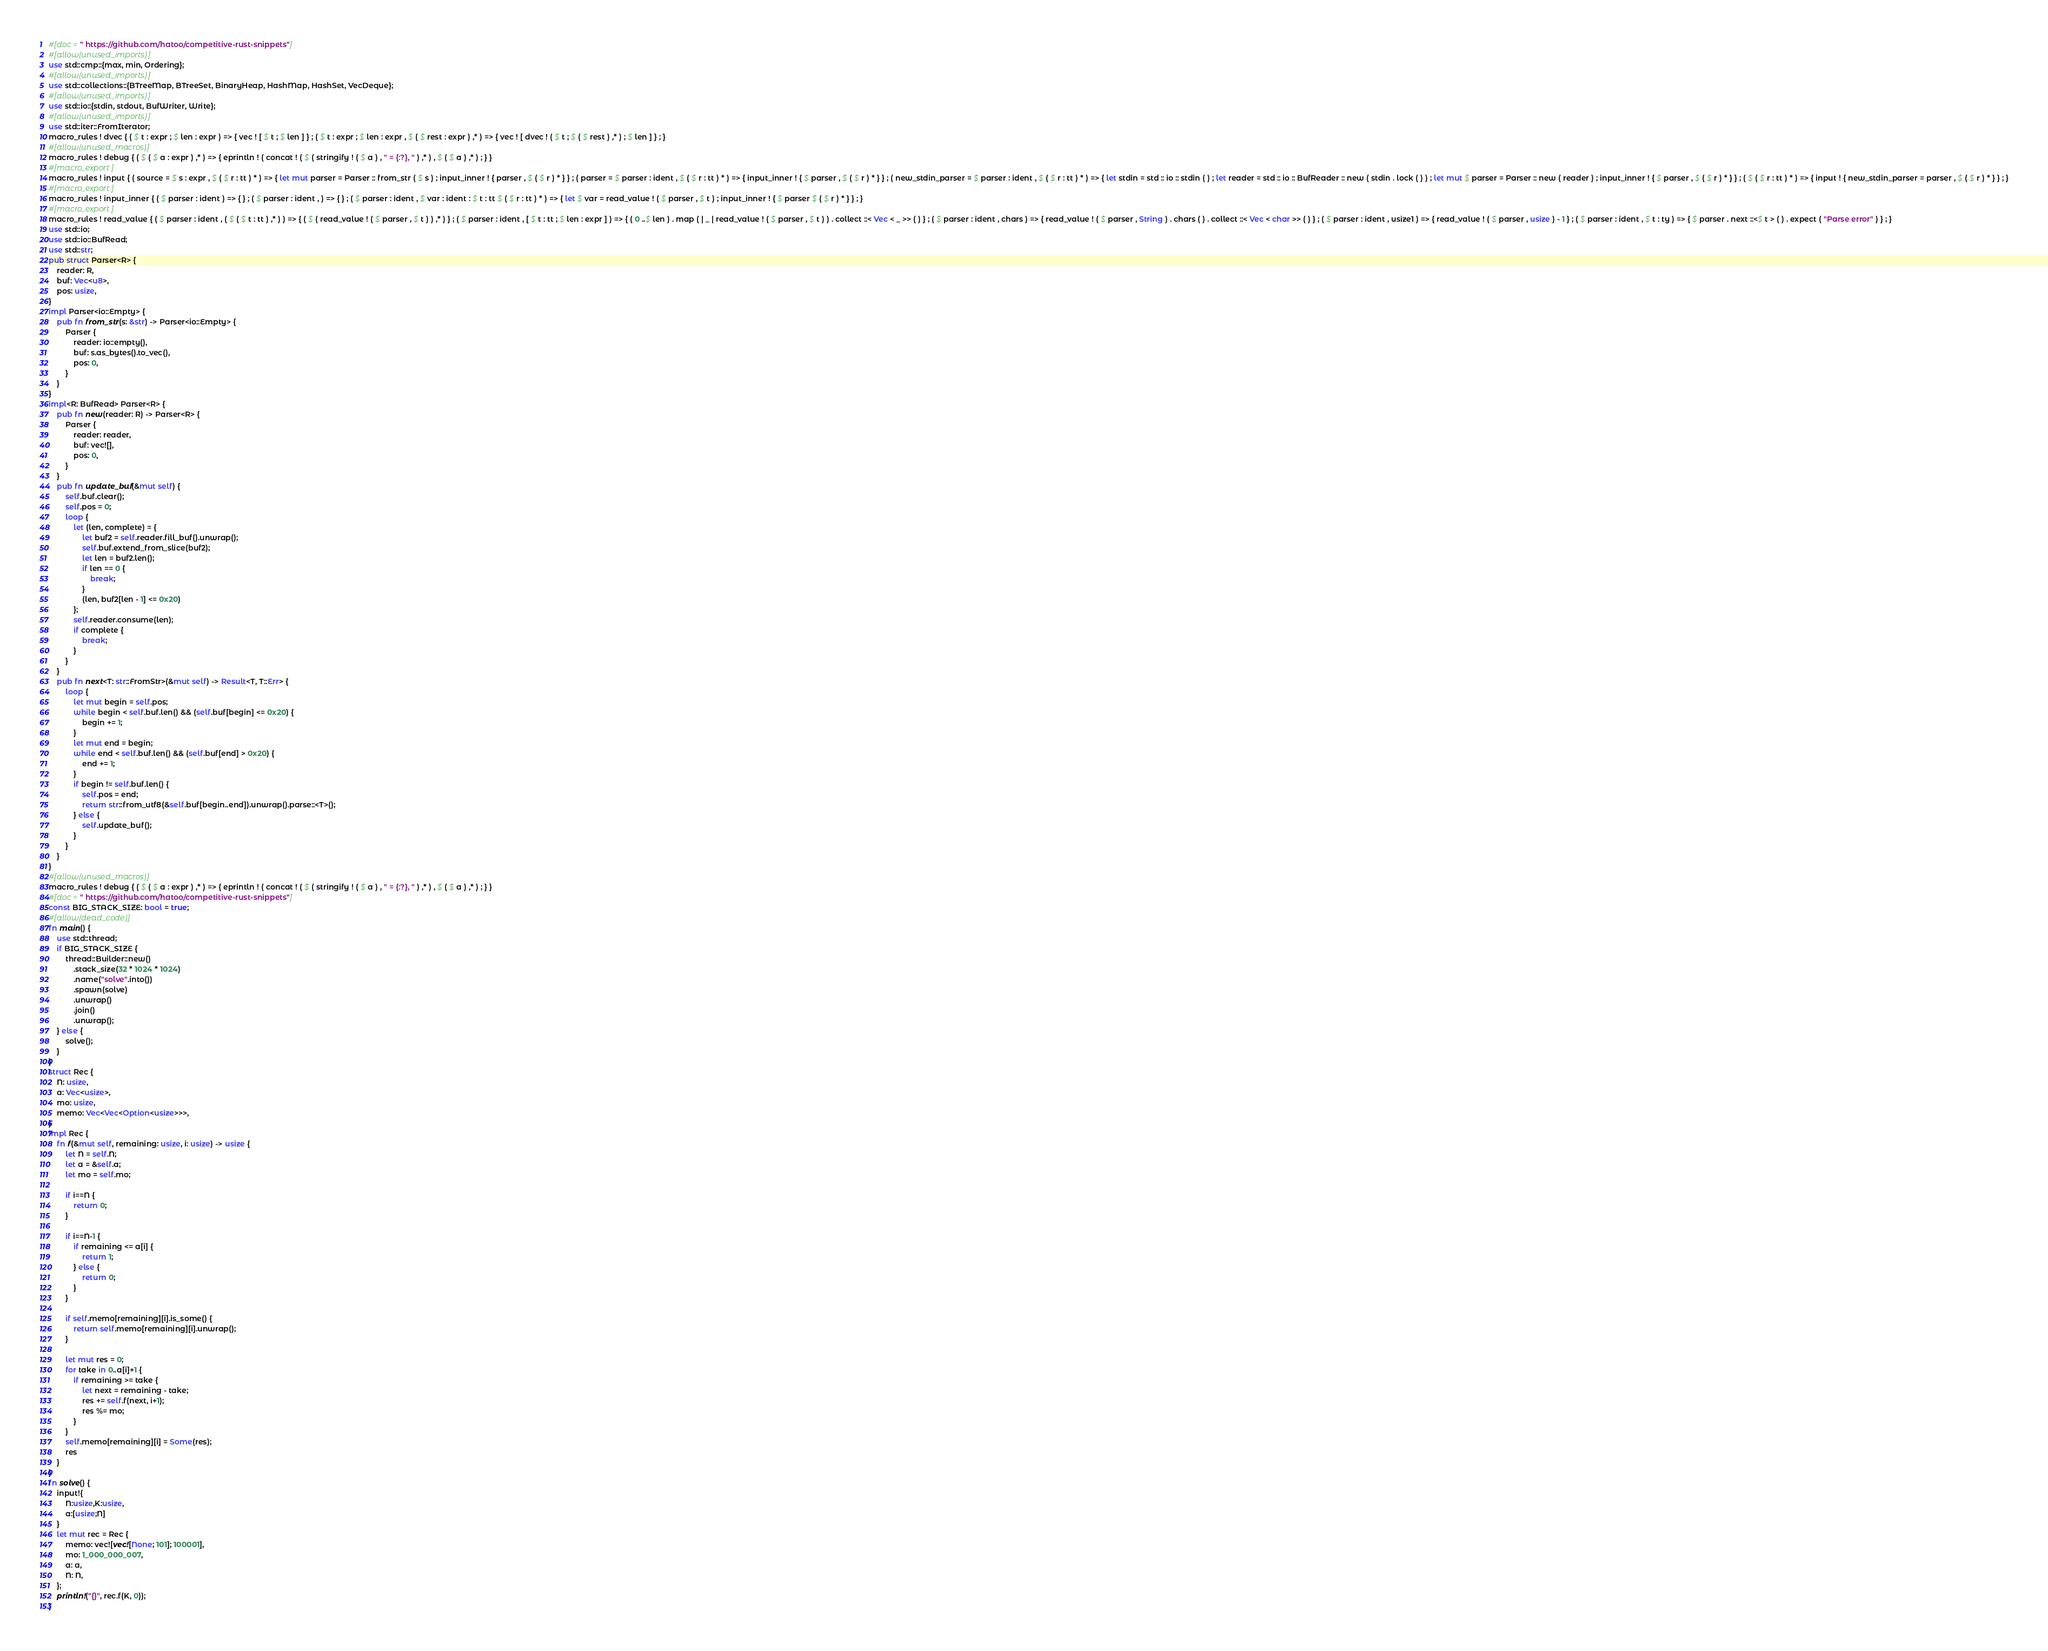<code> <loc_0><loc_0><loc_500><loc_500><_Rust_>#[doc = " https://github.com/hatoo/competitive-rust-snippets"]
#[allow(unused_imports)]
use std::cmp::{max, min, Ordering};
#[allow(unused_imports)]
use std::collections::{BTreeMap, BTreeSet, BinaryHeap, HashMap, HashSet, VecDeque};
#[allow(unused_imports)]
use std::io::{stdin, stdout, BufWriter, Write};
#[allow(unused_imports)]
use std::iter::FromIterator;
macro_rules ! dvec { ( $ t : expr ; $ len : expr ) => { vec ! [ $ t ; $ len ] } ; ( $ t : expr ; $ len : expr , $ ( $ rest : expr ) ,* ) => { vec ! [ dvec ! ( $ t ; $ ( $ rest ) ,* ) ; $ len ] } ; }
#[allow(unused_macros)]
macro_rules ! debug { ( $ ( $ a : expr ) ,* ) => { eprintln ! ( concat ! ( $ ( stringify ! ( $ a ) , " = {:?}, " ) ,* ) , $ ( $ a ) ,* ) ; } }
#[macro_export]
macro_rules ! input { ( source = $ s : expr , $ ( $ r : tt ) * ) => { let mut parser = Parser :: from_str ( $ s ) ; input_inner ! { parser , $ ( $ r ) * } } ; ( parser = $ parser : ident , $ ( $ r : tt ) * ) => { input_inner ! { $ parser , $ ( $ r ) * } } ; ( new_stdin_parser = $ parser : ident , $ ( $ r : tt ) * ) => { let stdin = std :: io :: stdin ( ) ; let reader = std :: io :: BufReader :: new ( stdin . lock ( ) ) ; let mut $ parser = Parser :: new ( reader ) ; input_inner ! { $ parser , $ ( $ r ) * } } ; ( $ ( $ r : tt ) * ) => { input ! { new_stdin_parser = parser , $ ( $ r ) * } } ; }
#[macro_export]
macro_rules ! input_inner { ( $ parser : ident ) => { } ; ( $ parser : ident , ) => { } ; ( $ parser : ident , $ var : ident : $ t : tt $ ( $ r : tt ) * ) => { let $ var = read_value ! ( $ parser , $ t ) ; input_inner ! { $ parser $ ( $ r ) * } } ; }
#[macro_export]
macro_rules ! read_value { ( $ parser : ident , ( $ ( $ t : tt ) ,* ) ) => { ( $ ( read_value ! ( $ parser , $ t ) ) ,* ) } ; ( $ parser : ident , [ $ t : tt ; $ len : expr ] ) => { ( 0 ..$ len ) . map ( | _ | read_value ! ( $ parser , $ t ) ) . collect ::< Vec < _ >> ( ) } ; ( $ parser : ident , chars ) => { read_value ! ( $ parser , String ) . chars ( ) . collect ::< Vec < char >> ( ) } ; ( $ parser : ident , usize1 ) => { read_value ! ( $ parser , usize ) - 1 } ; ( $ parser : ident , $ t : ty ) => { $ parser . next ::<$ t > ( ) . expect ( "Parse error" ) } ; }
use std::io;
use std::io::BufRead;
use std::str;
pub struct Parser<R> {
    reader: R,
    buf: Vec<u8>,
    pos: usize,
}
impl Parser<io::Empty> {
    pub fn from_str(s: &str) -> Parser<io::Empty> {
        Parser {
            reader: io::empty(),
            buf: s.as_bytes().to_vec(),
            pos: 0,
        }
    }
}
impl<R: BufRead> Parser<R> {
    pub fn new(reader: R) -> Parser<R> {
        Parser {
            reader: reader,
            buf: vec![],
            pos: 0,
        }
    }
    pub fn update_buf(&mut self) {
        self.buf.clear();
        self.pos = 0;
        loop {
            let (len, complete) = {
                let buf2 = self.reader.fill_buf().unwrap();
                self.buf.extend_from_slice(buf2);
                let len = buf2.len();
                if len == 0 {
                    break;
                }
                (len, buf2[len - 1] <= 0x20)
            };
            self.reader.consume(len);
            if complete {
                break;
            }
        }
    }
    pub fn next<T: str::FromStr>(&mut self) -> Result<T, T::Err> {
        loop {
            let mut begin = self.pos;
            while begin < self.buf.len() && (self.buf[begin] <= 0x20) {
                begin += 1;
            }
            let mut end = begin;
            while end < self.buf.len() && (self.buf[end] > 0x20) {
                end += 1;
            }
            if begin != self.buf.len() {
                self.pos = end;
                return str::from_utf8(&self.buf[begin..end]).unwrap().parse::<T>();
            } else {
                self.update_buf();
            }
        }
    }
}
#[allow(unused_macros)]
macro_rules ! debug { ( $ ( $ a : expr ) ,* ) => { eprintln ! ( concat ! ( $ ( stringify ! ( $ a ) , " = {:?}, " ) ,* ) , $ ( $ a ) ,* ) ; } }
#[doc = " https://github.com/hatoo/competitive-rust-snippets"]
const BIG_STACK_SIZE: bool = true;
#[allow(dead_code)]
fn main() {
    use std::thread;
    if BIG_STACK_SIZE {
        thread::Builder::new()
            .stack_size(32 * 1024 * 1024)
            .name("solve".into())
            .spawn(solve)
            .unwrap()
            .join()
            .unwrap();
    } else {
        solve();
    }
}
struct Rec {
    N: usize,
    a: Vec<usize>,
    mo: usize,
    memo: Vec<Vec<Option<usize>>>,
}
impl Rec {
    fn f(&mut self, remaining: usize, i: usize) -> usize {
        let N = self.N;
        let a = &self.a;
        let mo = self.mo;

        if i==N {
            return 0;
        }
        
        if i==N-1 {
            if remaining <= a[i] {
                return 1;
            } else {
                return 0;
            }
        }

        if self.memo[remaining][i].is_some() {
            return self.memo[remaining][i].unwrap();
        }

        let mut res = 0;
        for take in 0..a[i]+1 {
            if remaining >= take {
                let next = remaining - take;
                res += self.f(next, i+1);
                res %= mo;
            }
        }
        self.memo[remaining][i] = Some(res);
        res
    }
}
fn solve() {
    input!{
        N:usize,K:usize,
        a:[usize;N]
    }
    let mut rec = Rec {
        memo: vec![vec![None; 101]; 100001],
        mo: 1_000_000_007,
        a: a,
        N: N,
    };
    println!("{}", rec.f(K, 0));
}</code> 